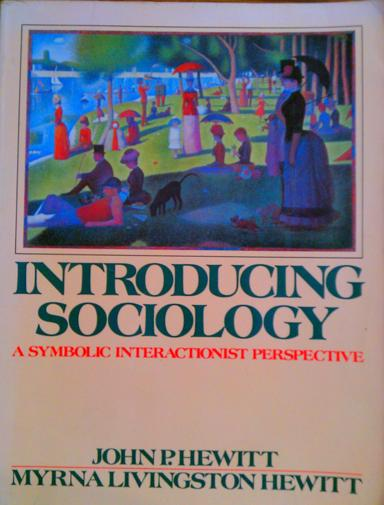What does the term "symbolic interactionist perspective" mean in the context of sociology? Symbolic interactionism is a framework within sociology that highlights the importance of human interactions and the use of symbols in creating social norms and structures. This perspective views society as a product of everyday interactions and emphasizes the subjective aspects of social life, rather than macro-level structures. It is particularly concerned with how individuals shape their world through communication and interpretation, a key understanding for sociologists studying human behavior and societal functions. 